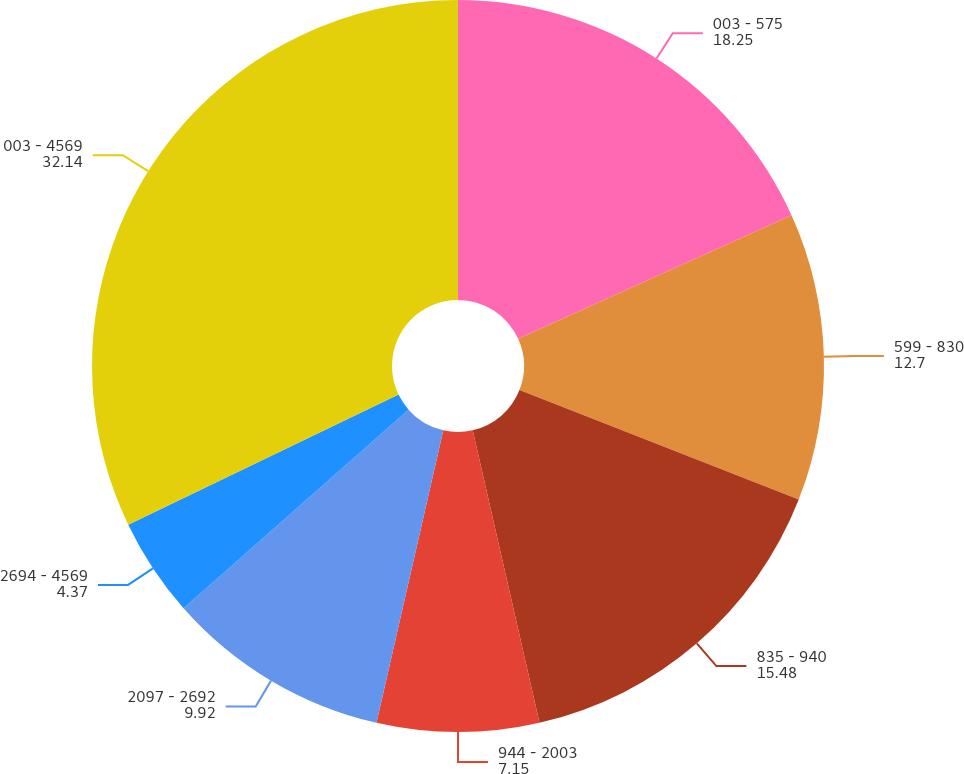Convert chart to OTSL. <chart><loc_0><loc_0><loc_500><loc_500><pie_chart><fcel>003 - 575<fcel>599 - 830<fcel>835 - 940<fcel>944 - 2003<fcel>2097 - 2692<fcel>2694 - 4569<fcel>003 - 4569<nl><fcel>18.25%<fcel>12.7%<fcel>15.48%<fcel>7.15%<fcel>9.92%<fcel>4.37%<fcel>32.14%<nl></chart> 